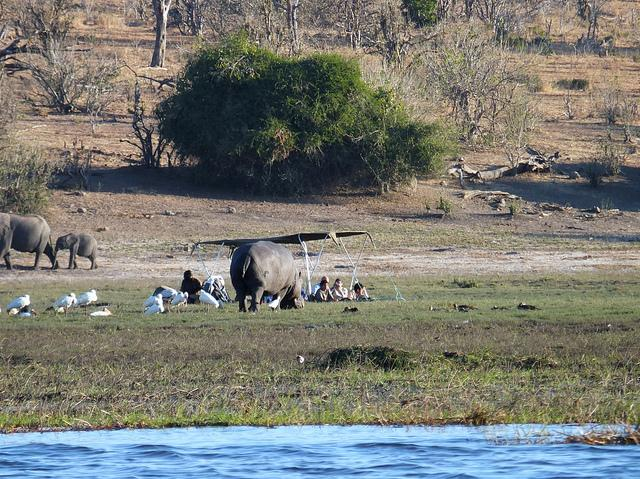Who are in the most danger? Please explain your reasoning. humans. The humans are in danger. 